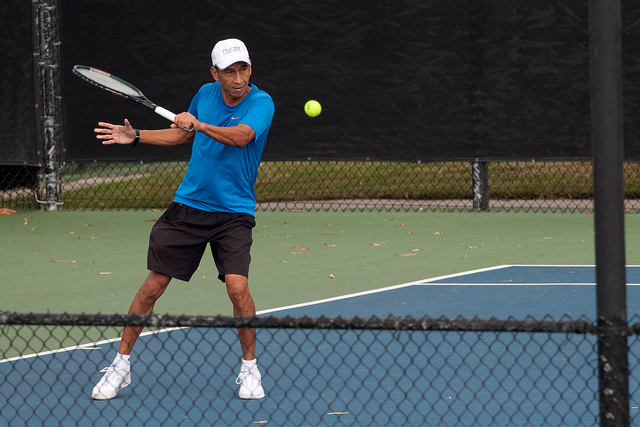<image>What letter is on the tennis racket? I don't know what letter is on the tennis racket. It can either be 'w', 'p', or none. What letter is on the tennis racket? I don't know what letter is on the tennis racket. It can be seen 'p', 'w' or there might be no letter at all. 